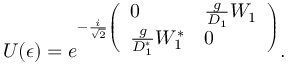<formula> <loc_0><loc_0><loc_500><loc_500>U ( \epsilon ) = e ^ { - { \frac { i } { \sqrt { 2 } } \left ( \begin{array} { l l } { 0 } & { { \frac { g } { D _ { 1 } } W _ { 1 } } } \\ { { \frac { g } { D _ { 1 } ^ { * } } W _ { 1 } ^ { * } } } & { 0 } \end{array} \right ) } } .</formula> 